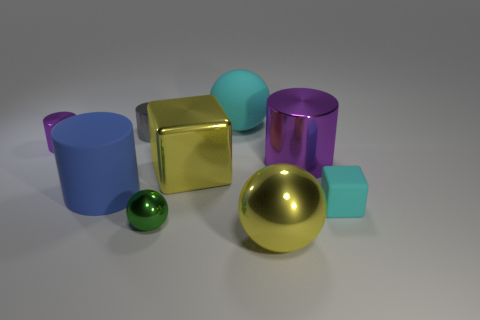What number of green shiny objects are behind the big sphere behind the big yellow block?
Your answer should be very brief. 0. Is there a big rubber thing that has the same shape as the small cyan rubber object?
Offer a terse response. No. There is a big thing that is left of the tiny gray thing; is its shape the same as the object left of the blue object?
Provide a short and direct response. Yes. How many things are either metal cylinders or tiny gray things?
Your response must be concise. 3. The blue matte thing that is the same shape as the gray object is what size?
Your response must be concise. Large. Are there more tiny cylinders that are in front of the small gray thing than large blue matte balls?
Make the answer very short. Yes. Is the gray object made of the same material as the blue thing?
Your answer should be compact. No. What number of things are purple things to the right of the big cyan thing or large objects that are behind the cyan rubber cube?
Offer a terse response. 4. What color is the other large thing that is the same shape as the big blue object?
Ensure brevity in your answer.  Purple. How many big balls have the same color as the tiny block?
Your answer should be very brief. 1. 